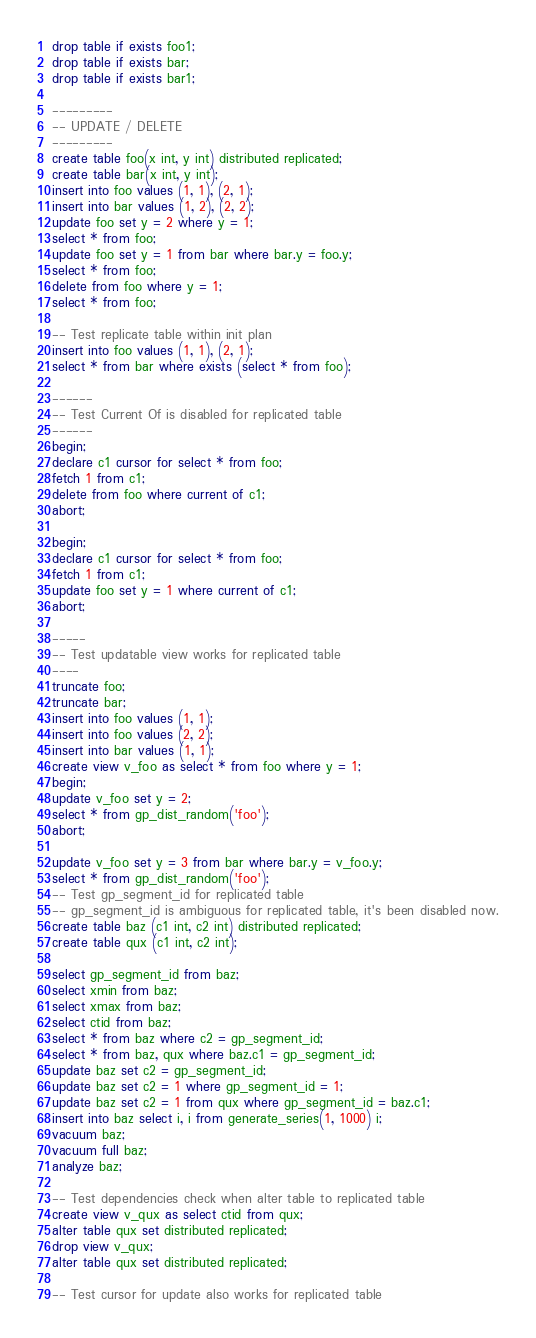<code> <loc_0><loc_0><loc_500><loc_500><_SQL_>drop table if exists foo1;
drop table if exists bar;
drop table if exists bar1;

---------
-- UPDATE / DELETE
---------
create table foo(x int, y int) distributed replicated;
create table bar(x int, y int);
insert into foo values (1, 1), (2, 1);
insert into bar values (1, 2), (2, 2);
update foo set y = 2 where y = 1;
select * from foo;
update foo set y = 1 from bar where bar.y = foo.y;
select * from foo;
delete from foo where y = 1;
select * from foo;

-- Test replicate table within init plan
insert into foo values (1, 1), (2, 1);
select * from bar where exists (select * from foo);

------
-- Test Current Of is disabled for replicated table
------
begin;
declare c1 cursor for select * from foo;
fetch 1 from c1;
delete from foo where current of c1;
abort;

begin;
declare c1 cursor for select * from foo;
fetch 1 from c1;
update foo set y = 1 where current of c1;
abort;

-----
-- Test updatable view works for replicated table
----
truncate foo;
truncate bar;
insert into foo values (1, 1);
insert into foo values (2, 2);
insert into bar values (1, 1);
create view v_foo as select * from foo where y = 1;
begin;
update v_foo set y = 2; 
select * from gp_dist_random('foo');
abort;

update v_foo set y = 3 from bar where bar.y = v_foo.y; 
select * from gp_dist_random('foo');
-- Test gp_segment_id for replicated table
-- gp_segment_id is ambiguous for replicated table, it's been disabled now.
create table baz (c1 int, c2 int) distributed replicated;
create table qux (c1 int, c2 int);

select gp_segment_id from baz;
select xmin from baz;
select xmax from baz;
select ctid from baz;
select * from baz where c2 = gp_segment_id;
select * from baz, qux where baz.c1 = gp_segment_id;
update baz set c2 = gp_segment_id;
update baz set c2 = 1 where gp_segment_id = 1;
update baz set c2 = 1 from qux where gp_segment_id = baz.c1;
insert into baz select i, i from generate_series(1, 1000) i;
vacuum baz;
vacuum full baz;
analyze baz;

-- Test dependencies check when alter table to replicated table
create view v_qux as select ctid from qux;
alter table qux set distributed replicated;
drop view v_qux;
alter table qux set distributed replicated;

-- Test cursor for update also works for replicated table</code> 